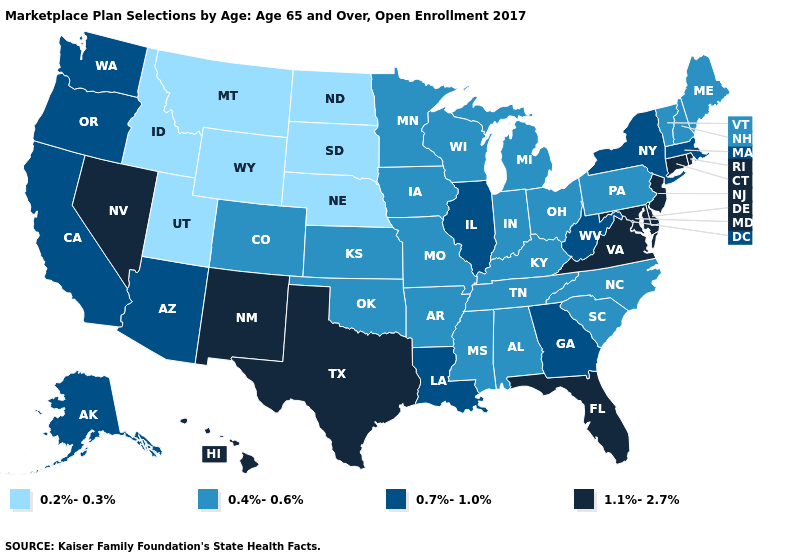Name the states that have a value in the range 0.2%-0.3%?
Be succinct. Idaho, Montana, Nebraska, North Dakota, South Dakota, Utah, Wyoming. Name the states that have a value in the range 0.4%-0.6%?
Concise answer only. Alabama, Arkansas, Colorado, Indiana, Iowa, Kansas, Kentucky, Maine, Michigan, Minnesota, Mississippi, Missouri, New Hampshire, North Carolina, Ohio, Oklahoma, Pennsylvania, South Carolina, Tennessee, Vermont, Wisconsin. Does Indiana have the highest value in the USA?
Keep it brief. No. Does the first symbol in the legend represent the smallest category?
Concise answer only. Yes. What is the lowest value in the USA?
Answer briefly. 0.2%-0.3%. Does Iowa have the same value as Michigan?
Concise answer only. Yes. Which states hav the highest value in the MidWest?
Quick response, please. Illinois. Which states have the lowest value in the USA?
Write a very short answer. Idaho, Montana, Nebraska, North Dakota, South Dakota, Utah, Wyoming. Does the first symbol in the legend represent the smallest category?
Concise answer only. Yes. Name the states that have a value in the range 0.4%-0.6%?
Quick response, please. Alabama, Arkansas, Colorado, Indiana, Iowa, Kansas, Kentucky, Maine, Michigan, Minnesota, Mississippi, Missouri, New Hampshire, North Carolina, Ohio, Oklahoma, Pennsylvania, South Carolina, Tennessee, Vermont, Wisconsin. Name the states that have a value in the range 0.7%-1.0%?
Give a very brief answer. Alaska, Arizona, California, Georgia, Illinois, Louisiana, Massachusetts, New York, Oregon, Washington, West Virginia. Does Wisconsin have a higher value than Michigan?
Keep it brief. No. What is the value of Ohio?
Answer briefly. 0.4%-0.6%. What is the value of Indiana?
Write a very short answer. 0.4%-0.6%. What is the value of North Dakota?
Write a very short answer. 0.2%-0.3%. 